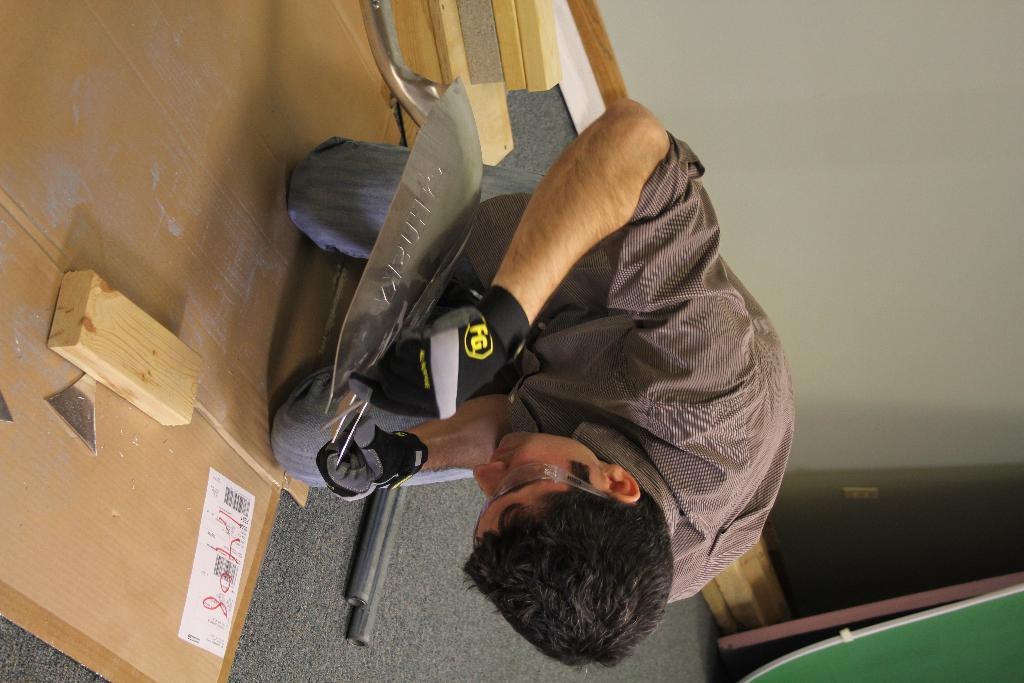What is the main feature of the image? There are many plants in the image. What is the person wearing while performing an action? The person is wearing gloves. What is the person cutting in the image? The person is cutting a metal spatula. What is on the ground in the image? There is a carpet on the ground and poles on the ground. What can be seen in the background of the image? There is a wall in the background. Reasoning: Let's think step by breaking down the conversation step by step. We start by identifying the main subject of the image, which is the plants. Then, we describe the person's actions and attire, focusing on the gloves. Next, we identify the object the person is cutting, which is a metal spatula. We then describe the ground and background elements, mentioning the carpet, poles, and wall. Each question is designed to elicit a specific detail about the image that is known from the provided facts. Absurd Question/Answer: What statement does the person make while cutting the spatula in the image? There is no dialogue or statement present in the image; it only shows a person cutting a metal spatula while wearing gloves. What birthday celebration is taking place in the image? There is no indication of a birthday celebration in the image; it only shows a person cutting a metal spatula while wearing gloves, surrounded by plants. 